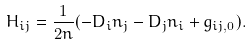Convert formula to latex. <formula><loc_0><loc_0><loc_500><loc_500>H _ { i j } = \frac { 1 } { 2 n } ( - D _ { i } n _ { j } - D _ { j } n _ { i } + g _ { i j , 0 } ) .</formula> 